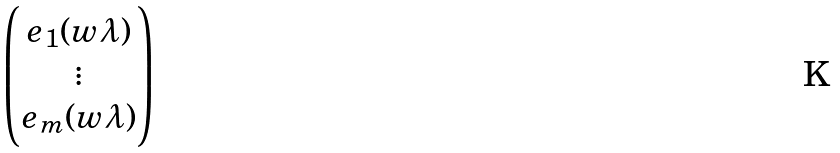Convert formula to latex. <formula><loc_0><loc_0><loc_500><loc_500>\begin{pmatrix} e _ { 1 } ( w \lambda ) \\ \vdots \\ e _ { m } ( w \lambda ) \end{pmatrix}</formula> 